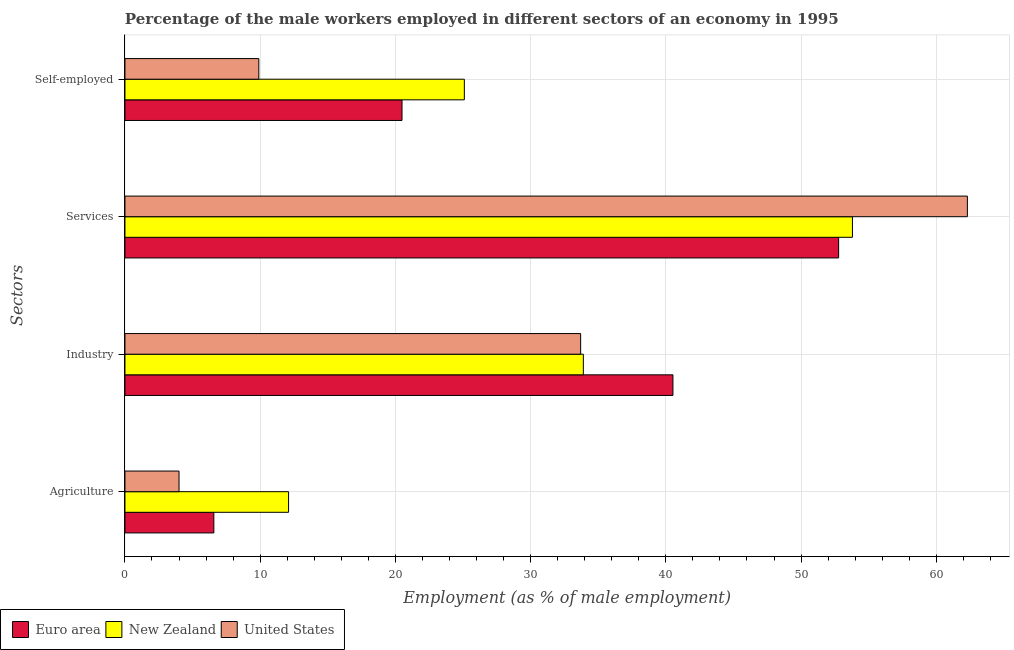How many different coloured bars are there?
Give a very brief answer. 3. Are the number of bars per tick equal to the number of legend labels?
Your answer should be very brief. Yes. Are the number of bars on each tick of the Y-axis equal?
Keep it short and to the point. Yes. How many bars are there on the 2nd tick from the top?
Ensure brevity in your answer.  3. What is the label of the 2nd group of bars from the top?
Your answer should be compact. Services. What is the percentage of male workers in agriculture in Euro area?
Ensure brevity in your answer.  6.57. Across all countries, what is the maximum percentage of male workers in services?
Keep it short and to the point. 62.3. Across all countries, what is the minimum percentage of self employed male workers?
Keep it short and to the point. 9.9. In which country was the percentage of self employed male workers maximum?
Keep it short and to the point. New Zealand. In which country was the percentage of self employed male workers minimum?
Provide a short and direct response. United States. What is the total percentage of male workers in agriculture in the graph?
Keep it short and to the point. 22.67. What is the difference between the percentage of self employed male workers in United States and the percentage of male workers in services in New Zealand?
Your answer should be compact. -43.9. What is the average percentage of male workers in services per country?
Your answer should be very brief. 56.29. What is the difference between the percentage of male workers in agriculture and percentage of self employed male workers in Euro area?
Ensure brevity in your answer.  -13.92. What is the ratio of the percentage of male workers in agriculture in Euro area to that in New Zealand?
Provide a succinct answer. 0.54. What is the difference between the highest and the second highest percentage of male workers in industry?
Your response must be concise. 6.63. What is the difference between the highest and the lowest percentage of male workers in industry?
Keep it short and to the point. 6.83. Is it the case that in every country, the sum of the percentage of male workers in services and percentage of male workers in industry is greater than the sum of percentage of self employed male workers and percentage of male workers in agriculture?
Provide a short and direct response. No. What does the 3rd bar from the top in Services represents?
Offer a very short reply. Euro area. How many countries are there in the graph?
Your answer should be very brief. 3. Does the graph contain any zero values?
Provide a succinct answer. No. What is the title of the graph?
Keep it short and to the point. Percentage of the male workers employed in different sectors of an economy in 1995. Does "Low income" appear as one of the legend labels in the graph?
Ensure brevity in your answer.  No. What is the label or title of the X-axis?
Offer a very short reply. Employment (as % of male employment). What is the label or title of the Y-axis?
Your response must be concise. Sectors. What is the Employment (as % of male employment) of Euro area in Agriculture?
Provide a succinct answer. 6.57. What is the Employment (as % of male employment) in New Zealand in Agriculture?
Make the answer very short. 12.1. What is the Employment (as % of male employment) in United States in Agriculture?
Your answer should be very brief. 4. What is the Employment (as % of male employment) of Euro area in Industry?
Offer a very short reply. 40.53. What is the Employment (as % of male employment) in New Zealand in Industry?
Ensure brevity in your answer.  33.9. What is the Employment (as % of male employment) in United States in Industry?
Provide a succinct answer. 33.7. What is the Employment (as % of male employment) in Euro area in Services?
Your answer should be very brief. 52.78. What is the Employment (as % of male employment) in New Zealand in Services?
Your response must be concise. 53.8. What is the Employment (as % of male employment) in United States in Services?
Offer a terse response. 62.3. What is the Employment (as % of male employment) in Euro area in Self-employed?
Ensure brevity in your answer.  20.49. What is the Employment (as % of male employment) in New Zealand in Self-employed?
Your answer should be very brief. 25.1. What is the Employment (as % of male employment) of United States in Self-employed?
Provide a succinct answer. 9.9. Across all Sectors, what is the maximum Employment (as % of male employment) in Euro area?
Keep it short and to the point. 52.78. Across all Sectors, what is the maximum Employment (as % of male employment) of New Zealand?
Your answer should be very brief. 53.8. Across all Sectors, what is the maximum Employment (as % of male employment) of United States?
Offer a terse response. 62.3. Across all Sectors, what is the minimum Employment (as % of male employment) in Euro area?
Your response must be concise. 6.57. Across all Sectors, what is the minimum Employment (as % of male employment) in New Zealand?
Make the answer very short. 12.1. What is the total Employment (as % of male employment) in Euro area in the graph?
Offer a terse response. 120.37. What is the total Employment (as % of male employment) in New Zealand in the graph?
Make the answer very short. 124.9. What is the total Employment (as % of male employment) of United States in the graph?
Keep it short and to the point. 109.9. What is the difference between the Employment (as % of male employment) in Euro area in Agriculture and that in Industry?
Provide a succinct answer. -33.95. What is the difference between the Employment (as % of male employment) in New Zealand in Agriculture and that in Industry?
Give a very brief answer. -21.8. What is the difference between the Employment (as % of male employment) in United States in Agriculture and that in Industry?
Your response must be concise. -29.7. What is the difference between the Employment (as % of male employment) of Euro area in Agriculture and that in Services?
Give a very brief answer. -46.21. What is the difference between the Employment (as % of male employment) in New Zealand in Agriculture and that in Services?
Offer a terse response. -41.7. What is the difference between the Employment (as % of male employment) in United States in Agriculture and that in Services?
Provide a short and direct response. -58.3. What is the difference between the Employment (as % of male employment) of Euro area in Agriculture and that in Self-employed?
Provide a succinct answer. -13.92. What is the difference between the Employment (as % of male employment) in New Zealand in Agriculture and that in Self-employed?
Keep it short and to the point. -13. What is the difference between the Employment (as % of male employment) in Euro area in Industry and that in Services?
Offer a terse response. -12.25. What is the difference between the Employment (as % of male employment) in New Zealand in Industry and that in Services?
Your answer should be compact. -19.9. What is the difference between the Employment (as % of male employment) in United States in Industry and that in Services?
Provide a short and direct response. -28.6. What is the difference between the Employment (as % of male employment) in Euro area in Industry and that in Self-employed?
Your answer should be compact. 20.04. What is the difference between the Employment (as % of male employment) in United States in Industry and that in Self-employed?
Offer a terse response. 23.8. What is the difference between the Employment (as % of male employment) in Euro area in Services and that in Self-employed?
Offer a terse response. 32.29. What is the difference between the Employment (as % of male employment) of New Zealand in Services and that in Self-employed?
Your answer should be compact. 28.7. What is the difference between the Employment (as % of male employment) of United States in Services and that in Self-employed?
Your answer should be very brief. 52.4. What is the difference between the Employment (as % of male employment) of Euro area in Agriculture and the Employment (as % of male employment) of New Zealand in Industry?
Ensure brevity in your answer.  -27.33. What is the difference between the Employment (as % of male employment) in Euro area in Agriculture and the Employment (as % of male employment) in United States in Industry?
Ensure brevity in your answer.  -27.13. What is the difference between the Employment (as % of male employment) in New Zealand in Agriculture and the Employment (as % of male employment) in United States in Industry?
Make the answer very short. -21.6. What is the difference between the Employment (as % of male employment) in Euro area in Agriculture and the Employment (as % of male employment) in New Zealand in Services?
Ensure brevity in your answer.  -47.23. What is the difference between the Employment (as % of male employment) in Euro area in Agriculture and the Employment (as % of male employment) in United States in Services?
Ensure brevity in your answer.  -55.73. What is the difference between the Employment (as % of male employment) in New Zealand in Agriculture and the Employment (as % of male employment) in United States in Services?
Make the answer very short. -50.2. What is the difference between the Employment (as % of male employment) in Euro area in Agriculture and the Employment (as % of male employment) in New Zealand in Self-employed?
Make the answer very short. -18.53. What is the difference between the Employment (as % of male employment) of Euro area in Agriculture and the Employment (as % of male employment) of United States in Self-employed?
Offer a terse response. -3.33. What is the difference between the Employment (as % of male employment) in New Zealand in Agriculture and the Employment (as % of male employment) in United States in Self-employed?
Your response must be concise. 2.2. What is the difference between the Employment (as % of male employment) in Euro area in Industry and the Employment (as % of male employment) in New Zealand in Services?
Provide a succinct answer. -13.27. What is the difference between the Employment (as % of male employment) of Euro area in Industry and the Employment (as % of male employment) of United States in Services?
Keep it short and to the point. -21.77. What is the difference between the Employment (as % of male employment) in New Zealand in Industry and the Employment (as % of male employment) in United States in Services?
Provide a succinct answer. -28.4. What is the difference between the Employment (as % of male employment) of Euro area in Industry and the Employment (as % of male employment) of New Zealand in Self-employed?
Provide a short and direct response. 15.43. What is the difference between the Employment (as % of male employment) of Euro area in Industry and the Employment (as % of male employment) of United States in Self-employed?
Your response must be concise. 30.63. What is the difference between the Employment (as % of male employment) in New Zealand in Industry and the Employment (as % of male employment) in United States in Self-employed?
Give a very brief answer. 24. What is the difference between the Employment (as % of male employment) of Euro area in Services and the Employment (as % of male employment) of New Zealand in Self-employed?
Your answer should be very brief. 27.68. What is the difference between the Employment (as % of male employment) of Euro area in Services and the Employment (as % of male employment) of United States in Self-employed?
Your answer should be very brief. 42.88. What is the difference between the Employment (as % of male employment) of New Zealand in Services and the Employment (as % of male employment) of United States in Self-employed?
Your response must be concise. 43.9. What is the average Employment (as % of male employment) in Euro area per Sectors?
Keep it short and to the point. 30.09. What is the average Employment (as % of male employment) in New Zealand per Sectors?
Your answer should be very brief. 31.23. What is the average Employment (as % of male employment) of United States per Sectors?
Give a very brief answer. 27.48. What is the difference between the Employment (as % of male employment) in Euro area and Employment (as % of male employment) in New Zealand in Agriculture?
Offer a terse response. -5.53. What is the difference between the Employment (as % of male employment) in Euro area and Employment (as % of male employment) in United States in Agriculture?
Make the answer very short. 2.57. What is the difference between the Employment (as % of male employment) of New Zealand and Employment (as % of male employment) of United States in Agriculture?
Your response must be concise. 8.1. What is the difference between the Employment (as % of male employment) in Euro area and Employment (as % of male employment) in New Zealand in Industry?
Give a very brief answer. 6.63. What is the difference between the Employment (as % of male employment) in Euro area and Employment (as % of male employment) in United States in Industry?
Provide a succinct answer. 6.83. What is the difference between the Employment (as % of male employment) of Euro area and Employment (as % of male employment) of New Zealand in Services?
Give a very brief answer. -1.02. What is the difference between the Employment (as % of male employment) of Euro area and Employment (as % of male employment) of United States in Services?
Provide a succinct answer. -9.52. What is the difference between the Employment (as % of male employment) of New Zealand and Employment (as % of male employment) of United States in Services?
Provide a short and direct response. -8.5. What is the difference between the Employment (as % of male employment) in Euro area and Employment (as % of male employment) in New Zealand in Self-employed?
Your response must be concise. -4.61. What is the difference between the Employment (as % of male employment) in Euro area and Employment (as % of male employment) in United States in Self-employed?
Provide a short and direct response. 10.59. What is the difference between the Employment (as % of male employment) in New Zealand and Employment (as % of male employment) in United States in Self-employed?
Offer a very short reply. 15.2. What is the ratio of the Employment (as % of male employment) in Euro area in Agriculture to that in Industry?
Make the answer very short. 0.16. What is the ratio of the Employment (as % of male employment) of New Zealand in Agriculture to that in Industry?
Your response must be concise. 0.36. What is the ratio of the Employment (as % of male employment) of United States in Agriculture to that in Industry?
Keep it short and to the point. 0.12. What is the ratio of the Employment (as % of male employment) of Euro area in Agriculture to that in Services?
Make the answer very short. 0.12. What is the ratio of the Employment (as % of male employment) of New Zealand in Agriculture to that in Services?
Offer a terse response. 0.22. What is the ratio of the Employment (as % of male employment) in United States in Agriculture to that in Services?
Make the answer very short. 0.06. What is the ratio of the Employment (as % of male employment) of Euro area in Agriculture to that in Self-employed?
Provide a succinct answer. 0.32. What is the ratio of the Employment (as % of male employment) in New Zealand in Agriculture to that in Self-employed?
Your response must be concise. 0.48. What is the ratio of the Employment (as % of male employment) in United States in Agriculture to that in Self-employed?
Offer a very short reply. 0.4. What is the ratio of the Employment (as % of male employment) of Euro area in Industry to that in Services?
Offer a very short reply. 0.77. What is the ratio of the Employment (as % of male employment) in New Zealand in Industry to that in Services?
Your answer should be compact. 0.63. What is the ratio of the Employment (as % of male employment) of United States in Industry to that in Services?
Provide a succinct answer. 0.54. What is the ratio of the Employment (as % of male employment) in Euro area in Industry to that in Self-employed?
Provide a succinct answer. 1.98. What is the ratio of the Employment (as % of male employment) in New Zealand in Industry to that in Self-employed?
Provide a succinct answer. 1.35. What is the ratio of the Employment (as % of male employment) of United States in Industry to that in Self-employed?
Provide a succinct answer. 3.4. What is the ratio of the Employment (as % of male employment) of Euro area in Services to that in Self-employed?
Offer a terse response. 2.58. What is the ratio of the Employment (as % of male employment) in New Zealand in Services to that in Self-employed?
Ensure brevity in your answer.  2.14. What is the ratio of the Employment (as % of male employment) of United States in Services to that in Self-employed?
Your response must be concise. 6.29. What is the difference between the highest and the second highest Employment (as % of male employment) in Euro area?
Your answer should be compact. 12.25. What is the difference between the highest and the second highest Employment (as % of male employment) of United States?
Your response must be concise. 28.6. What is the difference between the highest and the lowest Employment (as % of male employment) in Euro area?
Provide a succinct answer. 46.21. What is the difference between the highest and the lowest Employment (as % of male employment) of New Zealand?
Make the answer very short. 41.7. What is the difference between the highest and the lowest Employment (as % of male employment) in United States?
Your answer should be very brief. 58.3. 